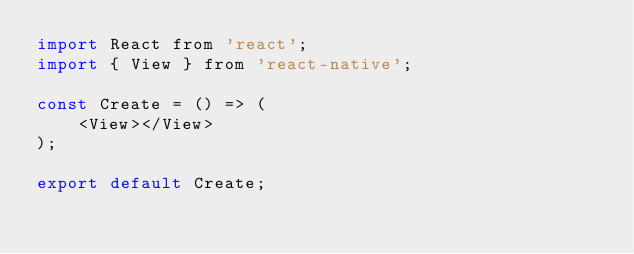<code> <loc_0><loc_0><loc_500><loc_500><_JavaScript_>import React from 'react';
import { View } from 'react-native';

const Create = () => (
    <View></View>
);

export default Create;</code> 